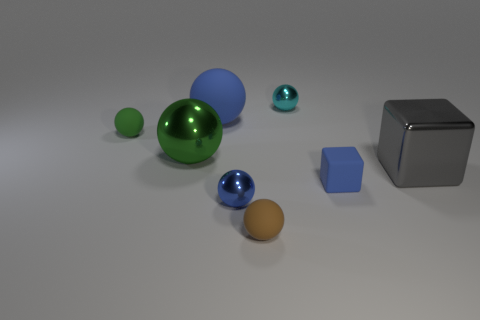Subtract all gray cylinders. How many green spheres are left? 2 Subtract 2 spheres. How many spheres are left? 4 Subtract all cyan spheres. How many spheres are left? 5 Subtract all tiny matte balls. How many balls are left? 4 Add 2 big metallic spheres. How many objects exist? 10 Subtract all gray balls. Subtract all blue cylinders. How many balls are left? 6 Subtract all spheres. How many objects are left? 2 Add 7 small metallic balls. How many small metallic balls are left? 9 Add 5 tiny blue metallic objects. How many tiny blue metallic objects exist? 6 Subtract 0 cyan blocks. How many objects are left? 8 